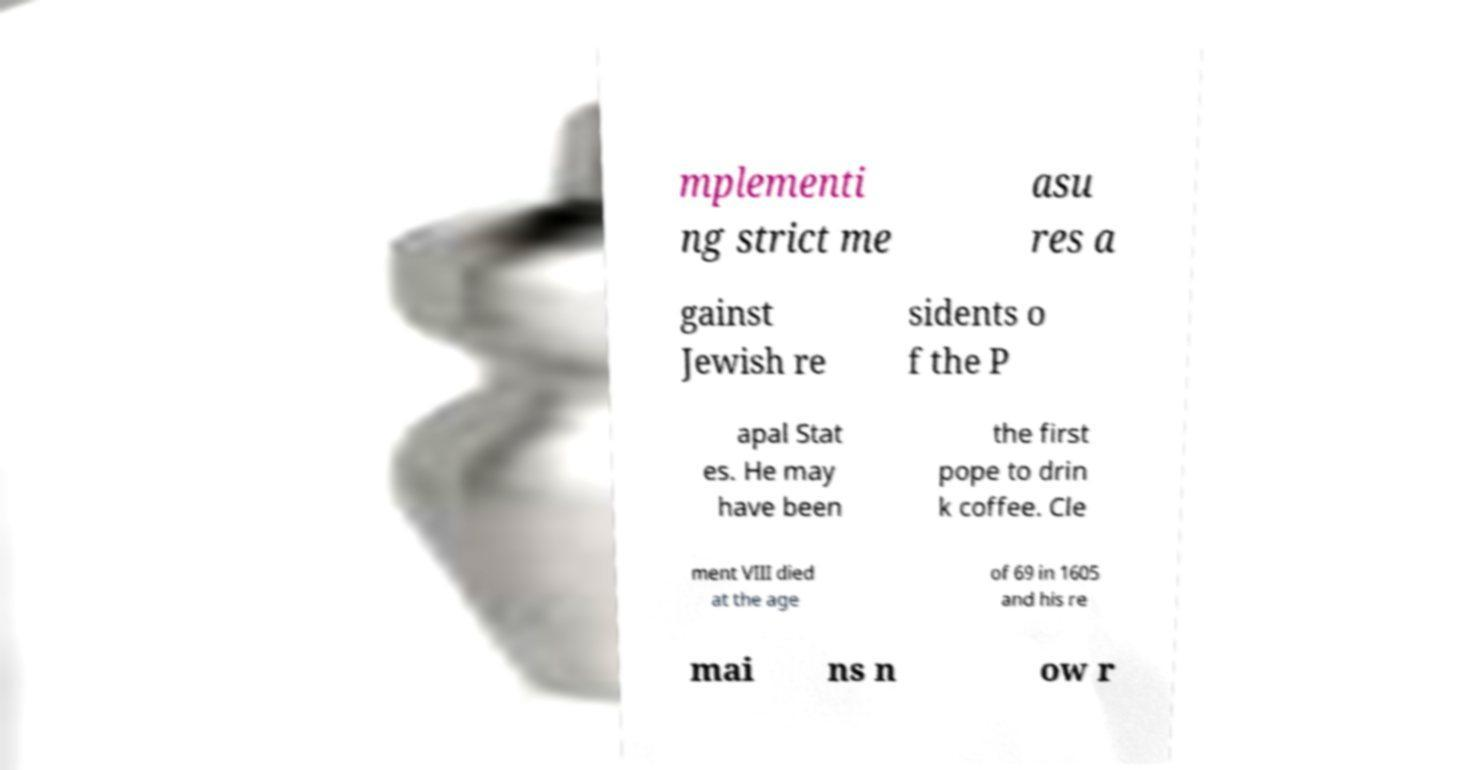For documentation purposes, I need the text within this image transcribed. Could you provide that? mplementi ng strict me asu res a gainst Jewish re sidents o f the P apal Stat es. He may have been the first pope to drin k coffee. Cle ment VIII died at the age of 69 in 1605 and his re mai ns n ow r 